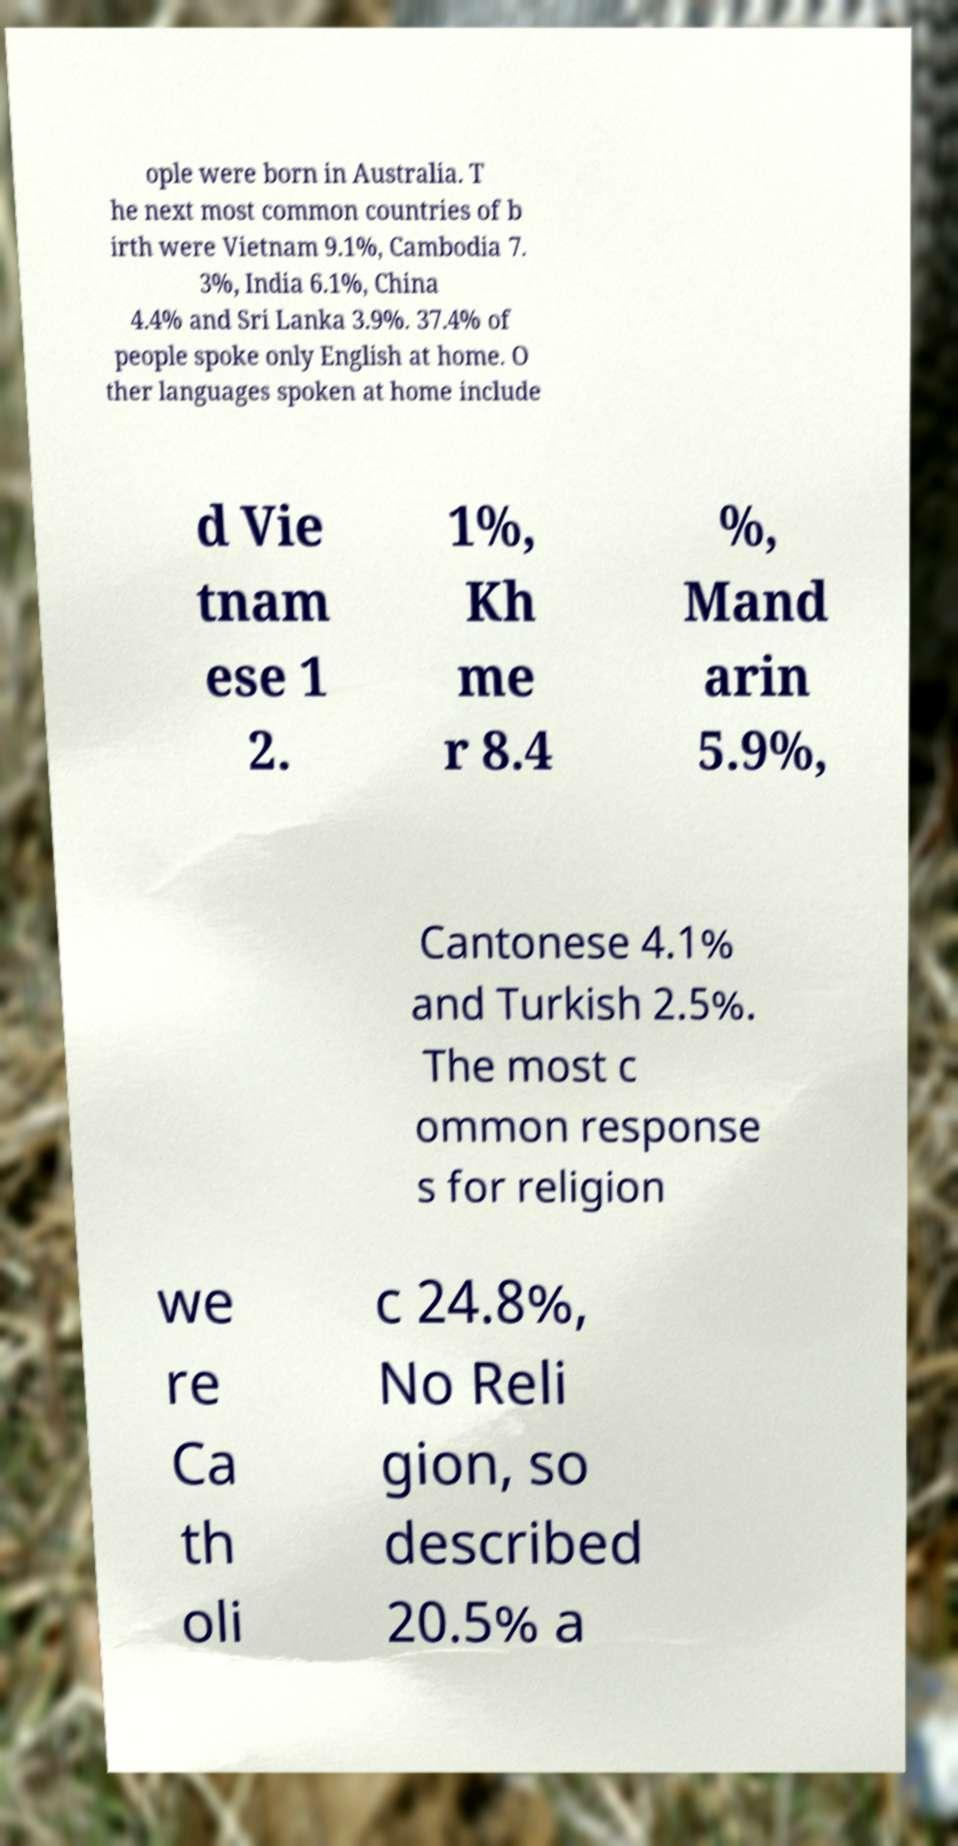There's text embedded in this image that I need extracted. Can you transcribe it verbatim? ople were born in Australia. T he next most common countries of b irth were Vietnam 9.1%, Cambodia 7. 3%, India 6.1%, China 4.4% and Sri Lanka 3.9%. 37.4% of people spoke only English at home. O ther languages spoken at home include d Vie tnam ese 1 2. 1%, Kh me r 8.4 %, Mand arin 5.9%, Cantonese 4.1% and Turkish 2.5%. The most c ommon response s for religion we re Ca th oli c 24.8%, No Reli gion, so described 20.5% a 